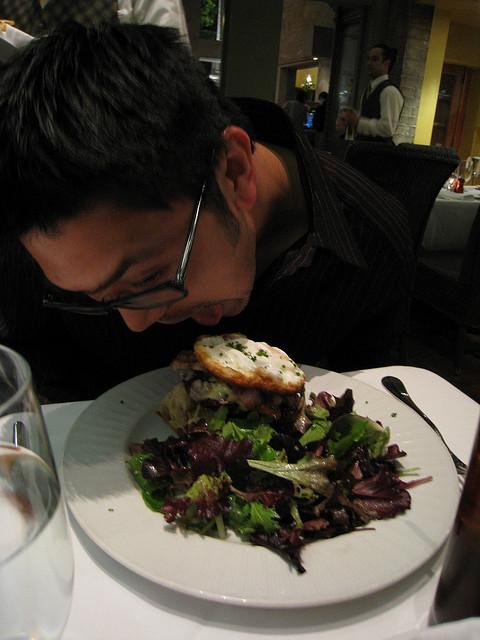Did he order a lot of food?
Give a very brief answer. Yes. What geometric shape is the plate?
Write a very short answer. Circle. What's in the glass?
Write a very short answer. Water. What type of wine is in the glass?
Keep it brief. White. What is he doing, or about to do?
Be succinct. Eat. Is there wine in the glass?
Quick response, please. No. Which meal is he eating?
Write a very short answer. Salad. Is that a larger than normal serving?
Give a very brief answer. No. How do you eat this?
Concise answer only. With fork. Is the meal gluten free?
Be succinct. No. Has this food been cooked?
Concise answer only. Yes. 